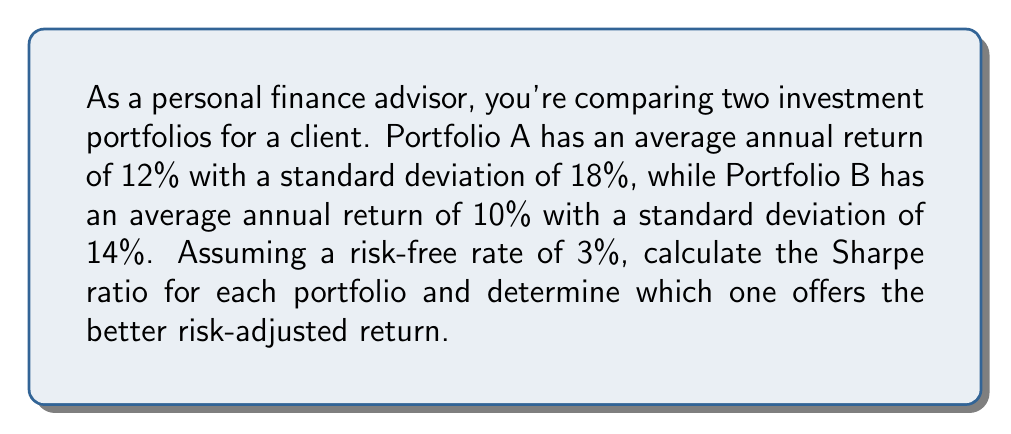What is the answer to this math problem? To solve this problem, we'll use the Sharpe ratio, which measures the risk-adjusted return of an investment. The formula for the Sharpe ratio is:

$$ \text{Sharpe Ratio} = \frac{R_p - R_f}{\sigma_p} $$

Where:
$R_p$ = Portfolio return
$R_f$ = Risk-free rate
$\sigma_p$ = Portfolio standard deviation

Step 1: Calculate the Sharpe ratio for Portfolio A
$$ \text{Sharpe Ratio}_A = \frac{12\% - 3\%}{18\%} = \frac{9\%}{18\%} = 0.5 $$

Step 2: Calculate the Sharpe ratio for Portfolio B
$$ \text{Sharpe Ratio}_B = \frac{10\% - 3\%}{14\%} = \frac{7\%}{14\%} = 0.5 $$

Step 3: Compare the Sharpe ratios
Both portfolios have the same Sharpe ratio of 0.5, indicating that they offer the same risk-adjusted return despite their different risk and return profiles.

Step 4: Interpretation
Although Portfolio A has a higher return (12% vs 10%), it also has higher risk (18% vs 14%). The Sharpe ratio shows that the additional return of Portfolio A is exactly offset by its additional risk, resulting in the same risk-adjusted performance as Portfolio B.
Answer: Both portfolios have a Sharpe ratio of 0.5, offering equal risk-adjusted returns. 